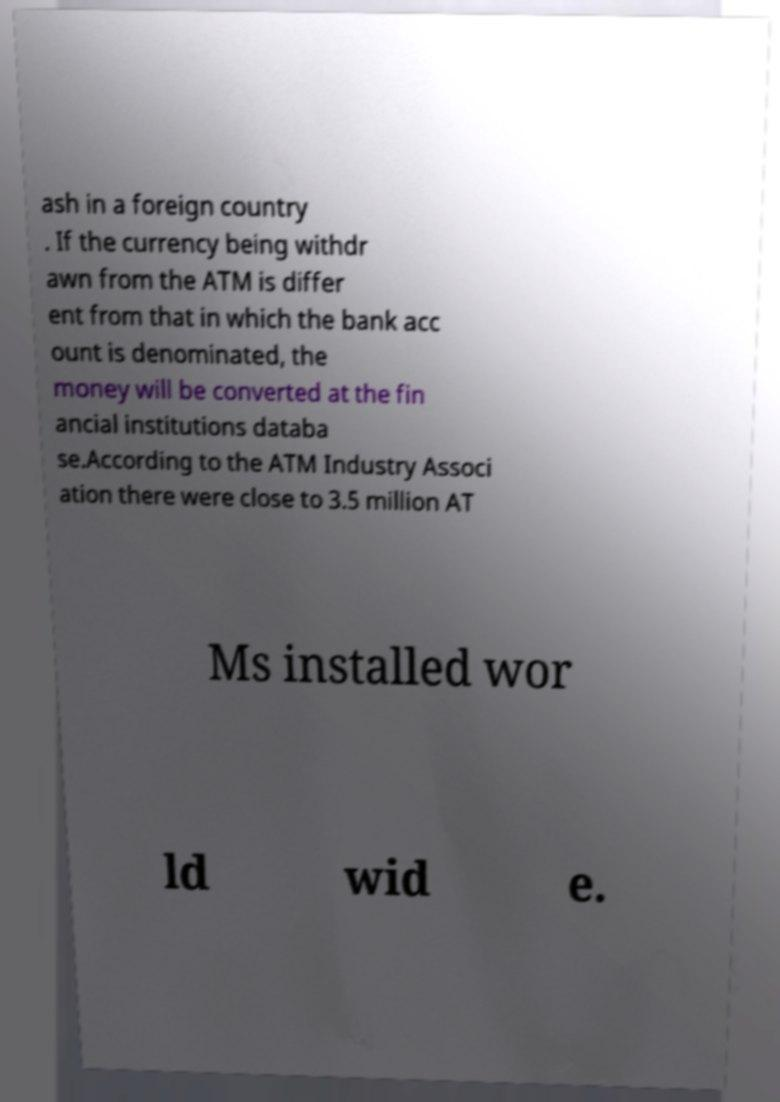Can you read and provide the text displayed in the image?This photo seems to have some interesting text. Can you extract and type it out for me? ash in a foreign country . If the currency being withdr awn from the ATM is differ ent from that in which the bank acc ount is denominated, the money will be converted at the fin ancial institutions databa se.According to the ATM Industry Associ ation there were close to 3.5 million AT Ms installed wor ld wid e. 